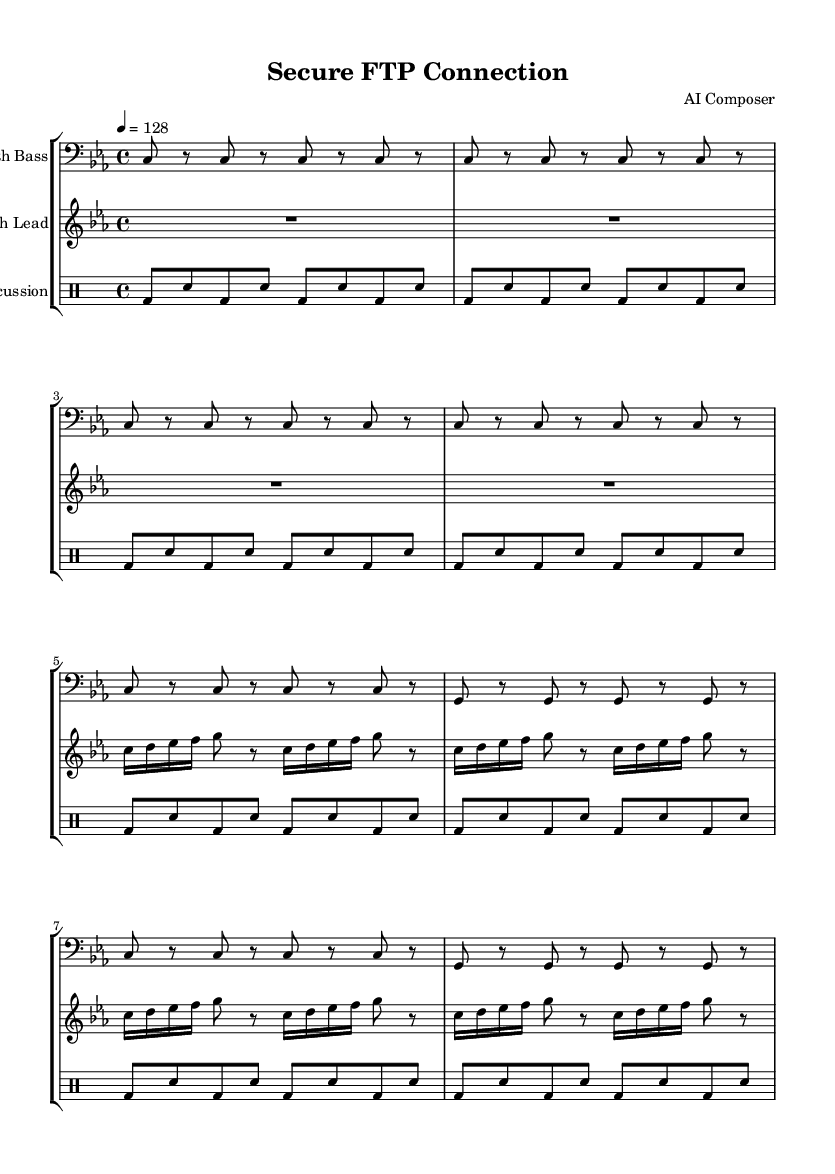What is the key signature of this music? The key signature is C minor, indicated by the presence of three flats (B♭, E♭, and A♭) in the context of the score.
Answer: C minor What is the time signature of the piece? The time signature is 4/4, which is displayed at the beginning of the score and indicates four beats per measure, with the quarter note getting one beat.
Answer: 4/4 What is the tempo marking in this music? The tempo marking is indicated as "4 = 128", which specifies the tempo to be played at a speed of 128 beats per minute.
Answer: 128 How many times is the main theme repeated? The main theme is repeated a total of two times, as shown in the repeated sections in both the synth bass and synth lead lines.
Answer: 2 What type of drum pattern is used throughout the piece? The drum pattern features a bass drum and snare alternation, which is characteristic of many techno tracks, maintaining a consistent driving rhythm throughout.
Answer: Bass drum and snare What note lengths are predominantly used in the synth lead? The predominant note lengths in the synth lead are sixteenth and eighth notes, which contribute to the rhythmic complexity typical of techno music.
Answer: Sixteenth and eighth notes What is the primary instrument used for the bass line? The primary instrument used for the bass line is the Synth Bass, as indicated by the label in the staff where the bass notes are written.
Answer: Synth Bass 